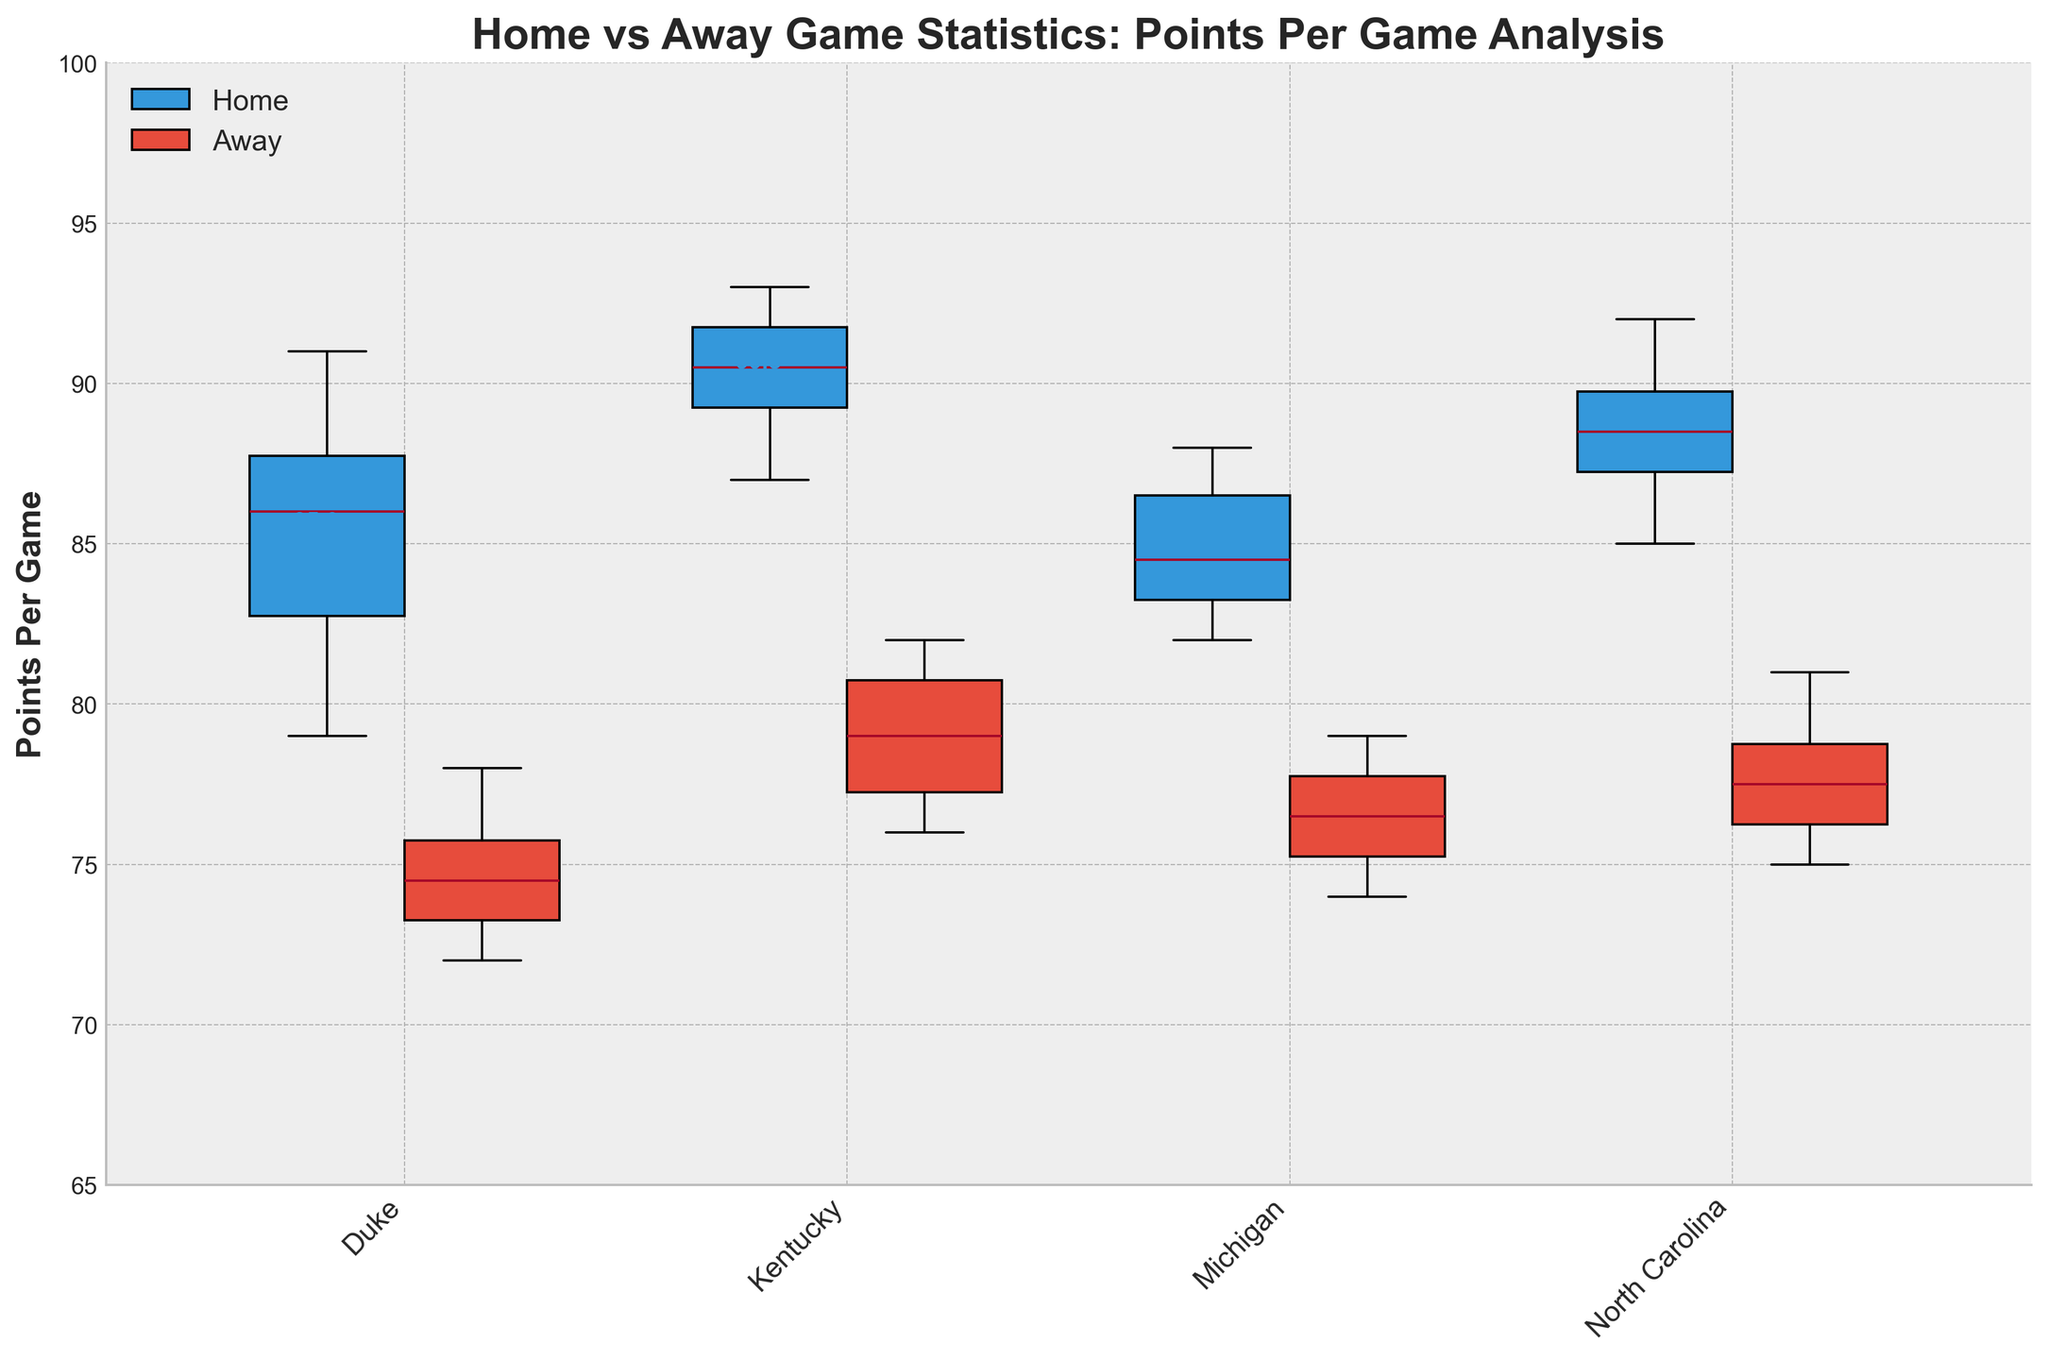what is the title of the figure? The title is the text at the top of the figure that describes what the plot is about. The title of this figure is "Home vs Away Game Statistics: Points Per Game Analysis".
Answer: Home vs Away Game Statistics: Points Per Game Analysis which team has the highest average points per game at home? To find the team with the highest average points per game at home, look at the average points indicated next to the home box plots. Kentucky has the highest value.
Answer: Kentucky which team scores fewer points on average when playing away? Compare the mean points per game for the away box plots of all the teams. Duke has the lowest average points per game when playing away.
Answer: Duke what is the range of points per game for North Carolina home games? The range is the difference between the maximum and minimum values inside the box plot for North Carolina home games. The highest value is 92 and the lowest value is 85. So, the range is 92 - 85.
Answer: 7 points which location generally has higher median points per game for Duke? For this, compare the median lines within the boxes for both home and away for Duke. The median is at a higher value for Home games.
Answer: Home how many data points does each group (home and away) have for each team? Each box plot has 6 data points as per the provided data. This includes the home and away groups for Duke, Kentucky, Michigan, and North Carolina.
Answer: 6 what are the median points per game values for Michigan at home and away? The median is the line within each boxplot. For Michigan home, it is closest to 84, and for away, it is around 77.
Answer: Home: 84, Away: 77 are there any teams where the home and away points distributions overlap significantly? Check the interquartile ranges of both home and away box plots. Michigan and North Carolina show significant overlap in their distributions.
Answer: Michigan, North Carolina which team sees the least difference in average points per game between home and away? Calculate the difference in average points by subtracting the away average from the home average for each team. Michigan has the least difference (Home: 84.2 – Away: 76.5 = 7.7).
Answer: Michigan 